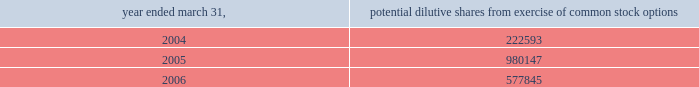Abiomed , inc .
And subsidiaries notes to consolidated financial statements 2014 ( continued ) the calculation of diluted weighted-average shares outstanding for the fiscal years ended march 31 , 2004 , 2005 and 2006 excludes potential stock from unexercised stock options that have an exercise price below the average market price as shown below .
Year ended march 31 , potential dilutive shares from exercise of common stock options .
The calculation of diluted weighted average shares outstanding excludes unissued shares of common stock associated with outstanding stock options that have exercise prices greater than the average market price .
For the fiscal years ending march 31 , 2004 , 2005 and 2006 , the weighted average number of these potential shares totaled 1908347 , 825014 and 1417130 shares , respectively .
The calculation of diluted weighted average shares outstanding for these fiscal years also excludes warrants to purchase 400000 share of common stock issued in connection with the acquisition of intellectual property ( see note 5 ) .
( k ) cash and cash equivalents the company classifies any marketable security with a maturity date of 90 days or less at the time of purchase as a cash equivalent .
At march 31 , 2005 and march 31 , 2006 , the company had restricted cash of approximately $ 97000 and $ 261000 , respectively , which are included in other assets at march 31 , 2005 and prepaid expenses and other current assets at march 31 , 2006 , respectively .
This cash represents security deposits held in the company 2019s european banks for certain facility and auto leases .
( l ) marketable securities and long-term investments the company classifies any security with a maturity date of greater than 90 days at the time of purchase as marketable securities and classifies marketable securities with a maturity date of greater than one year from the balance sheet date as long-term investments based upon the ability and intent of the company .
In accordance with statement of financial accounting standards ( sfas ) no .
115 , accounting for certain investments in debt and equity securities , securities that the company has the positive intent and ability to hold to maturity are reported at amortized cost and classified as held-to-maturity securities .
At march 31 , 2006 the held-to-maturity investment portfolio consisted primarily of government securities and corporate bonds with maturities of one year or less .
The amortized cost , including interest receivable , and market value of held 2013to-maturity short-term marketable securities were approximately $ 29669000 and $ 29570000 at march 31 , 2005 , and $ 16901000 and $ 16866000 at march 31 , 2006 , respectively .
The company has classified its portion of the investment portfolio consisting of corporate asset-backed securities as available-for 2013sale securities .
The cost of these securities approximates market value and was $ 4218000 at march 31 , 2005 and $ 6102000 at march 31 , 2006 .
Principal payments of these available-for-sale securities are typically made on an expected pre-determined basis rather than on the longer contractual maturity date. .
At march 31 , 2006 , how much loss could be recognized if they sold the held-to-maturity investment portfolio? 
Computations: (29669000 - 29570000)
Answer: 99000.0. 